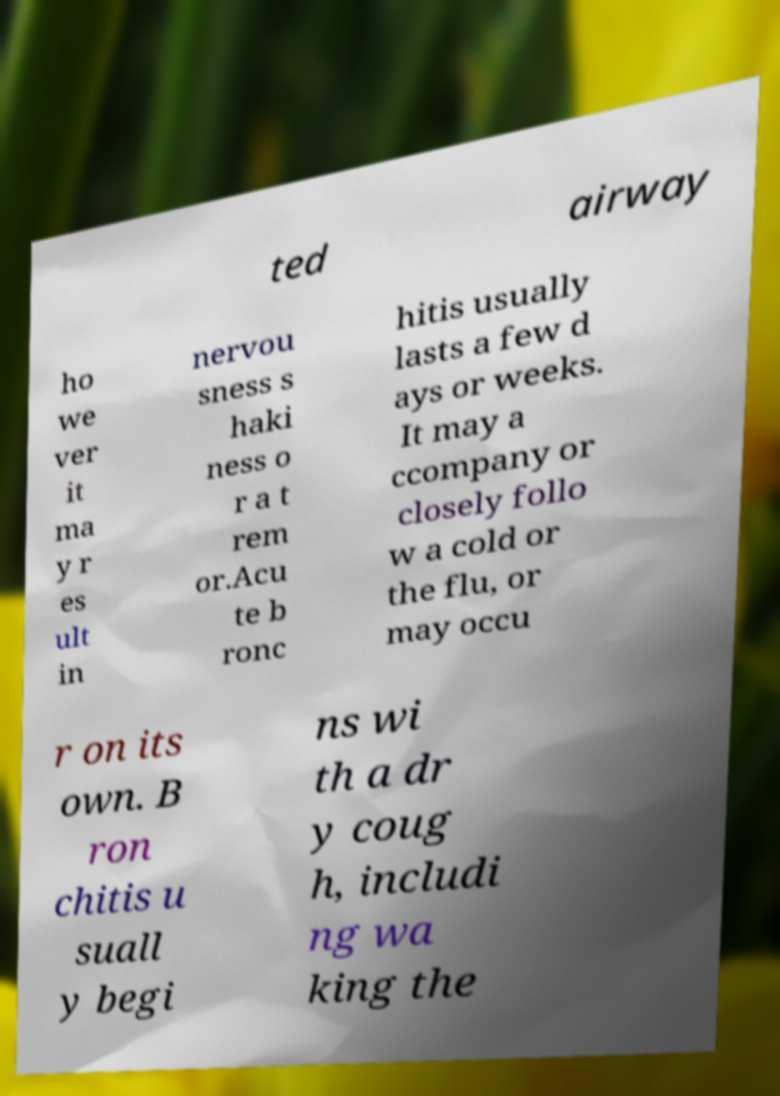What messages or text are displayed in this image? I need them in a readable, typed format. ted airway ho we ver it ma y r es ult in nervou sness s haki ness o r a t rem or.Acu te b ronc hitis usually lasts a few d ays or weeks. It may a ccompany or closely follo w a cold or the flu, or may occu r on its own. B ron chitis u suall y begi ns wi th a dr y coug h, includi ng wa king the 